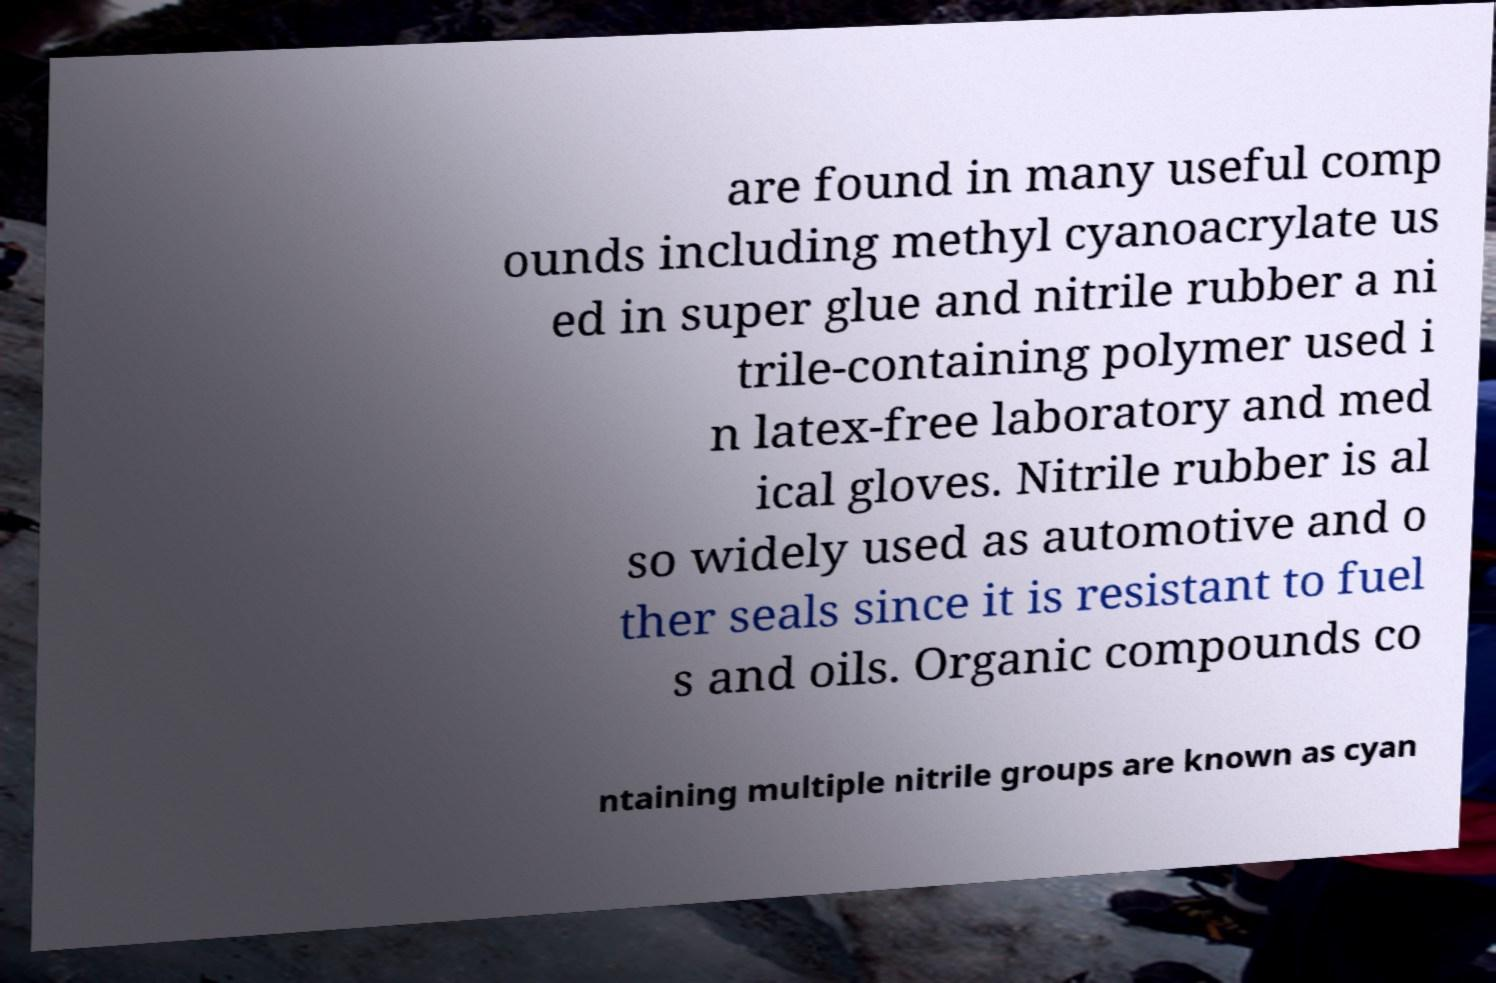Please identify and transcribe the text found in this image. are found in many useful comp ounds including methyl cyanoacrylate us ed in super glue and nitrile rubber a ni trile-containing polymer used i n latex-free laboratory and med ical gloves. Nitrile rubber is al so widely used as automotive and o ther seals since it is resistant to fuel s and oils. Organic compounds co ntaining multiple nitrile groups are known as cyan 